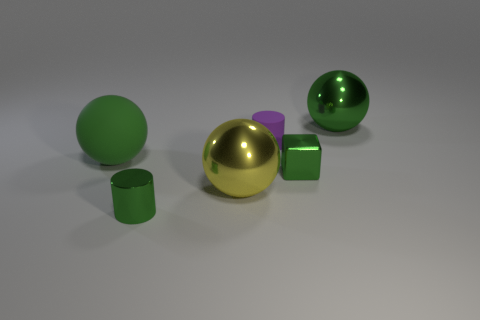Add 3 small purple cylinders. How many objects exist? 9 Subtract all cylinders. How many objects are left? 4 Subtract 0 brown cylinders. How many objects are left? 6 Subtract all gray metallic cubes. Subtract all large yellow spheres. How many objects are left? 5 Add 5 metal objects. How many metal objects are left? 9 Add 6 tiny green metallic cylinders. How many tiny green metallic cylinders exist? 7 